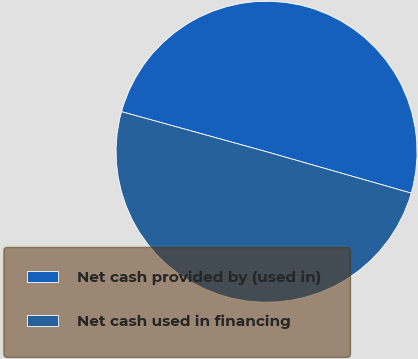Convert chart to OTSL. <chart><loc_0><loc_0><loc_500><loc_500><pie_chart><fcel>Net cash provided by (used in)<fcel>Net cash used in financing<nl><fcel>50.14%<fcel>49.86%<nl></chart> 